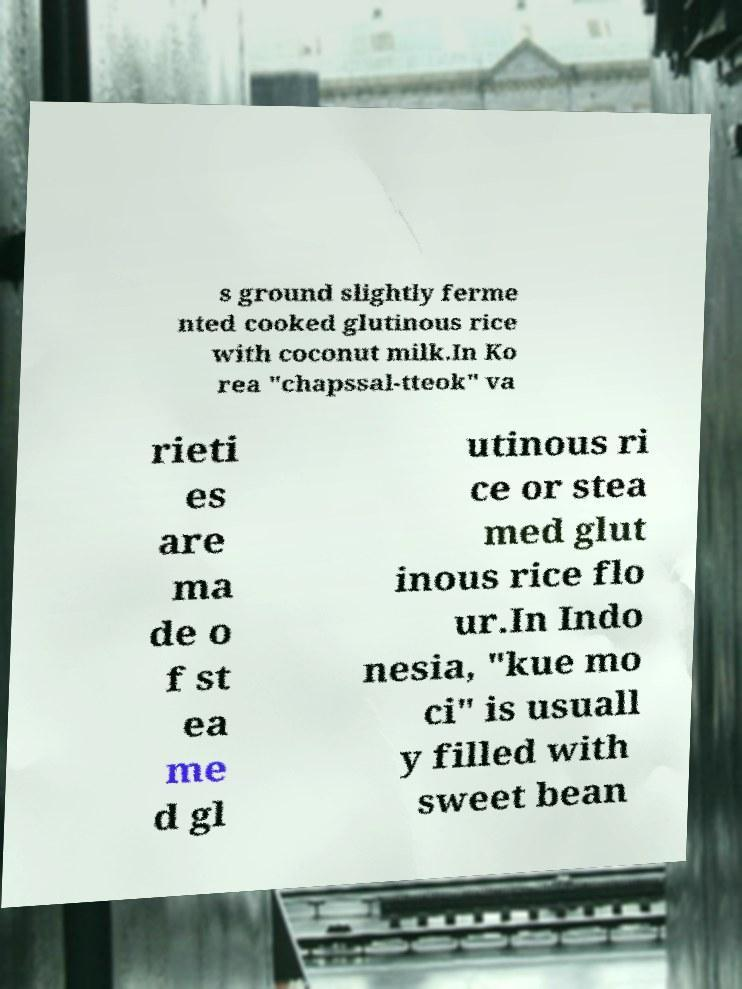Please identify and transcribe the text found in this image. s ground slightly ferme nted cooked glutinous rice with coconut milk.In Ko rea "chapssal-tteok" va rieti es are ma de o f st ea me d gl utinous ri ce or stea med glut inous rice flo ur.In Indo nesia, "kue mo ci" is usuall y filled with sweet bean 